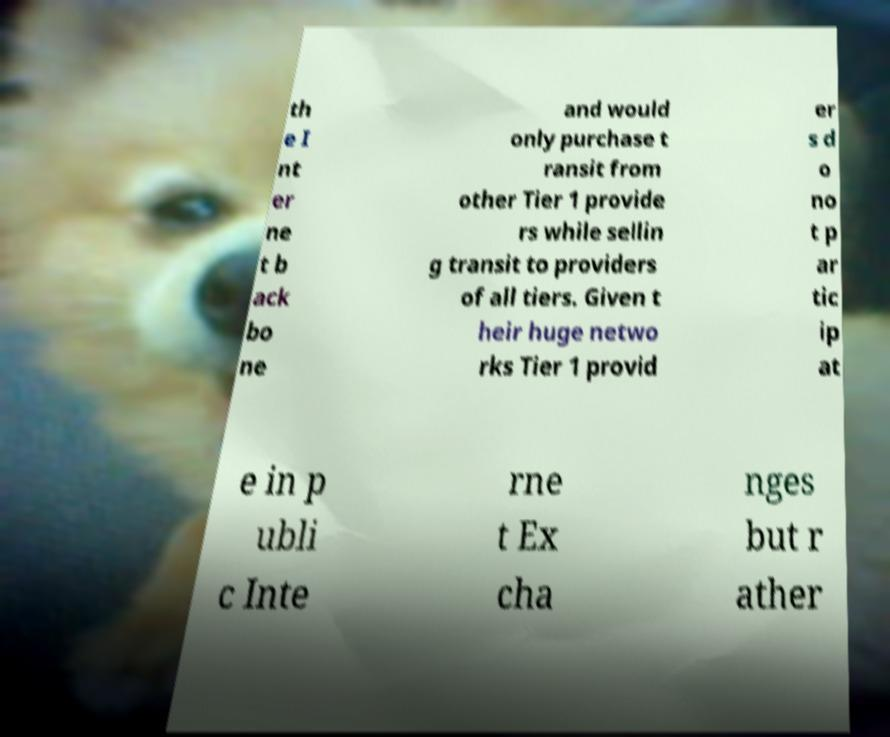Please identify and transcribe the text found in this image. th e I nt er ne t b ack bo ne and would only purchase t ransit from other Tier 1 provide rs while sellin g transit to providers of all tiers. Given t heir huge netwo rks Tier 1 provid er s d o no t p ar tic ip at e in p ubli c Inte rne t Ex cha nges but r ather 